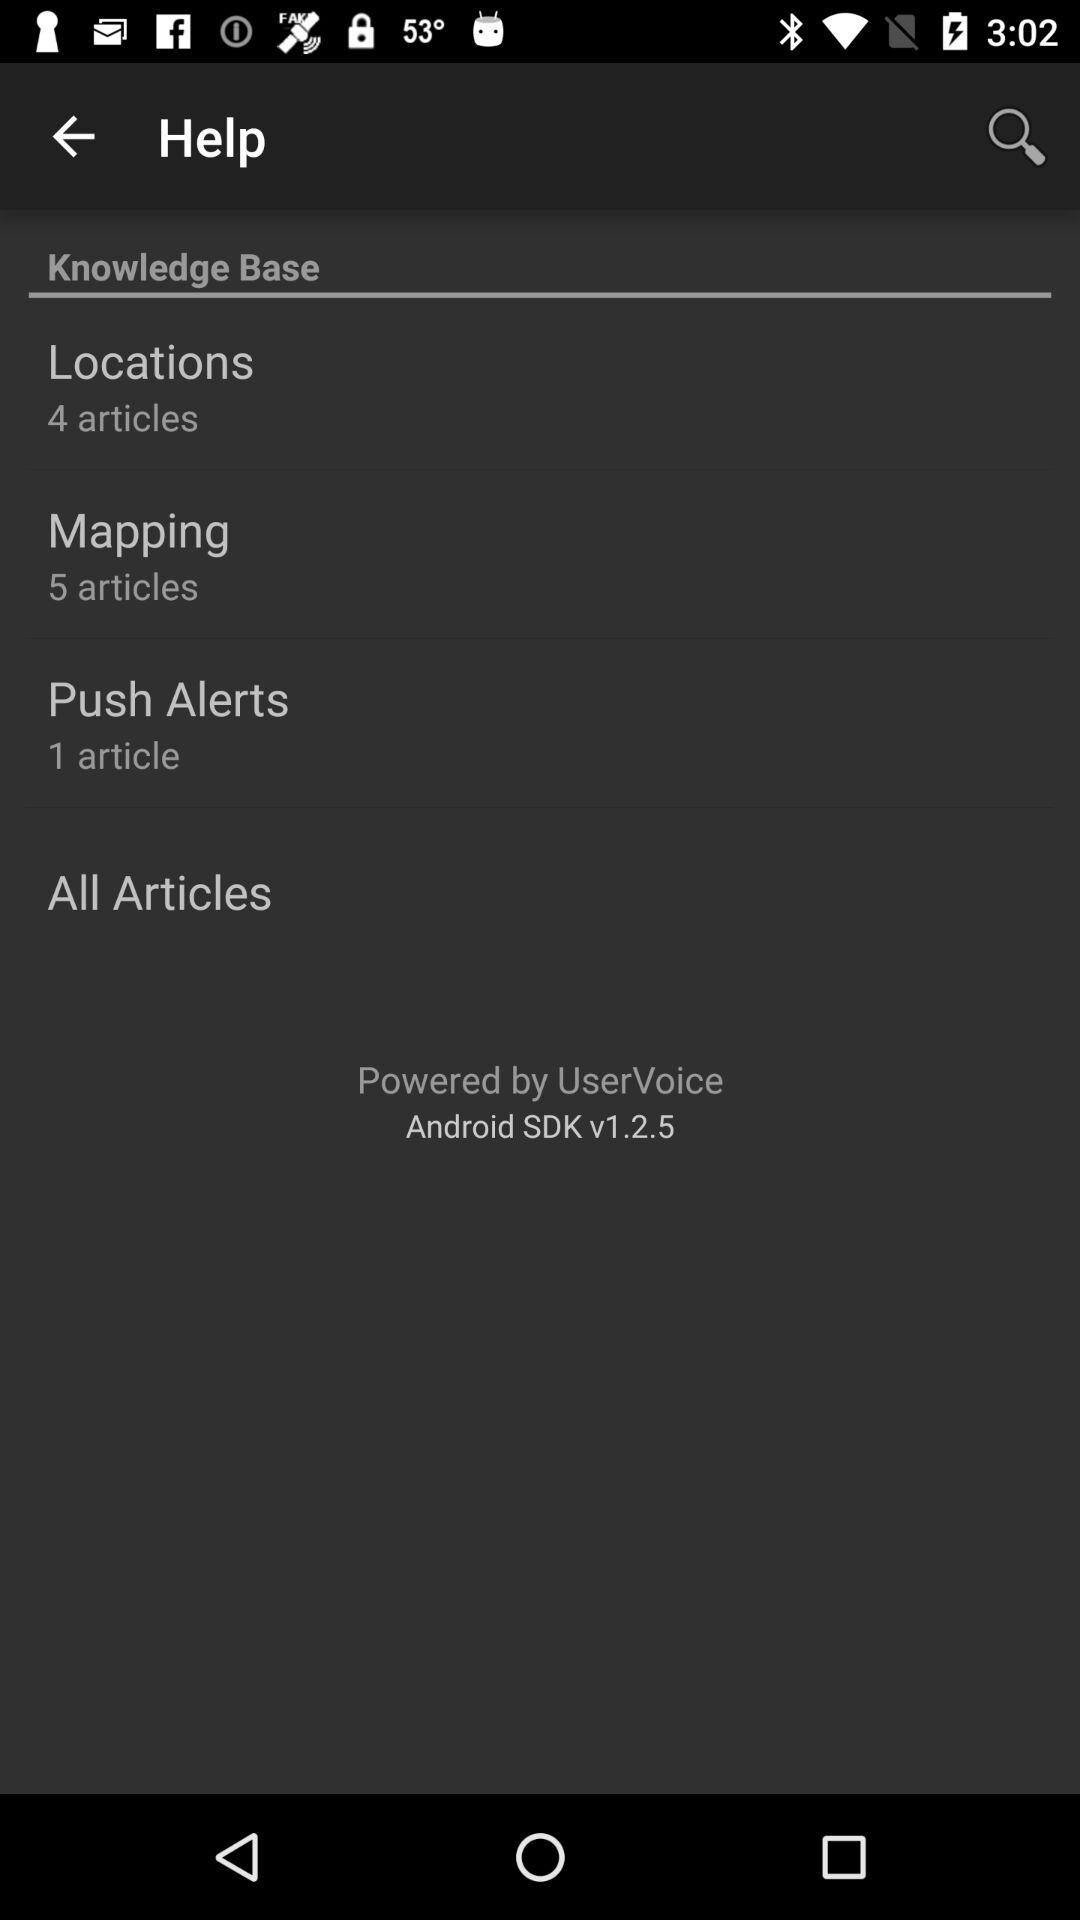What is the count of articles in "Mapping"? The count of articles in "Mapping" is 5. 